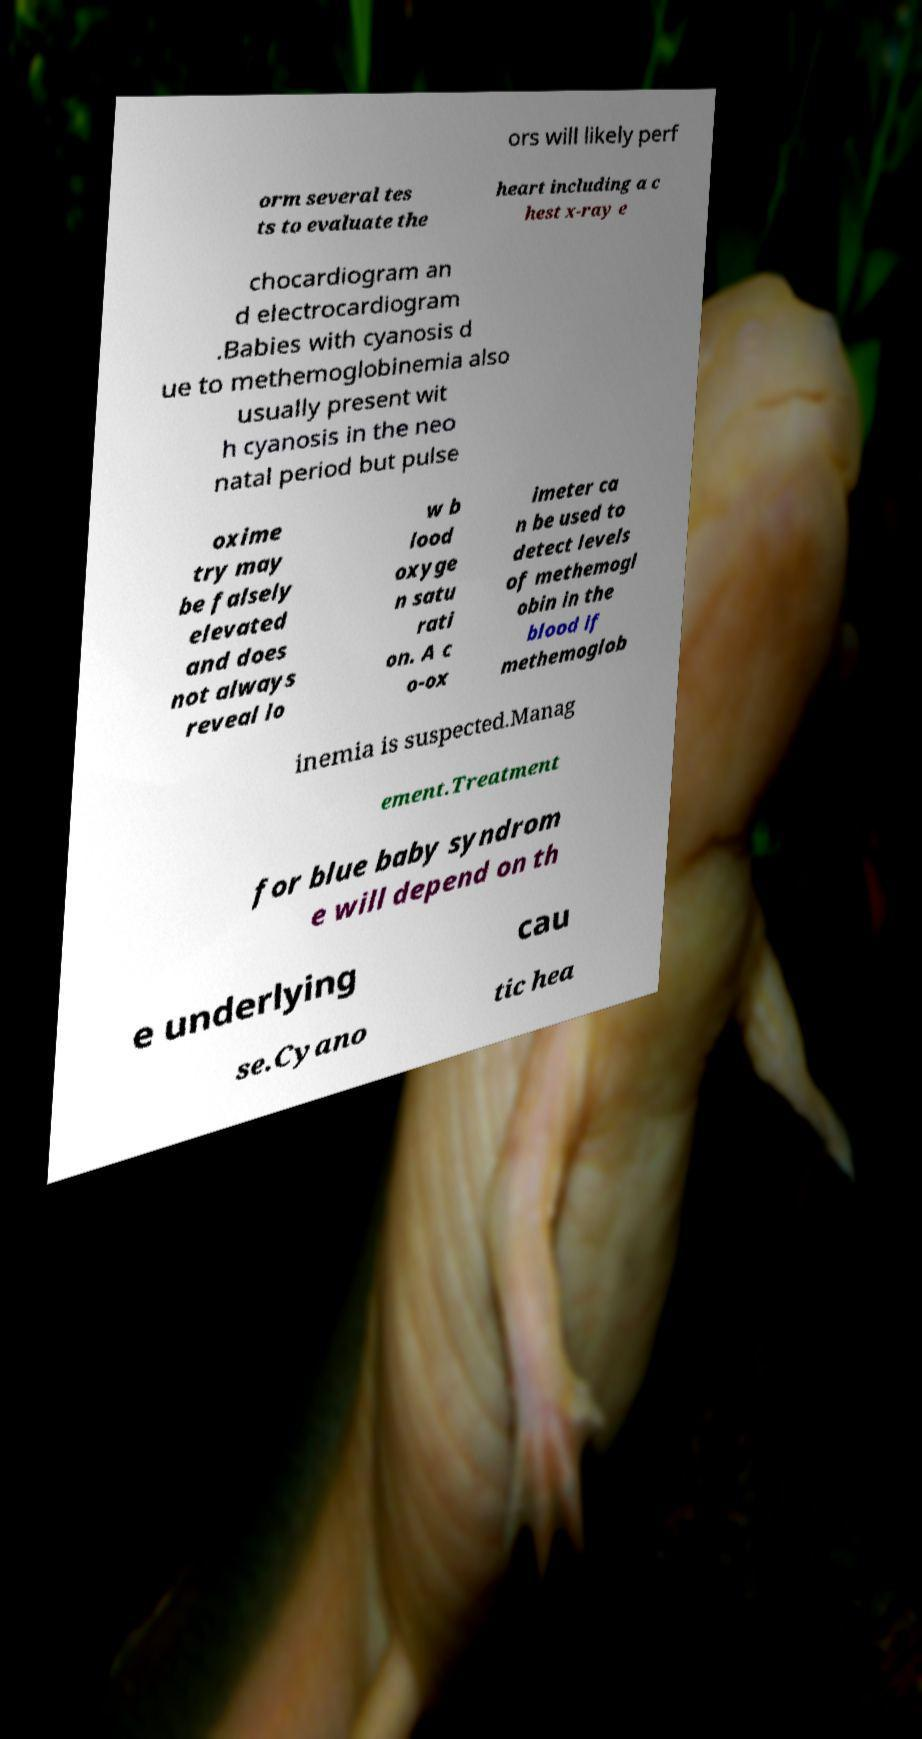Could you extract and type out the text from this image? ors will likely perf orm several tes ts to evaluate the heart including a c hest x-ray e chocardiogram an d electrocardiogram .Babies with cyanosis d ue to methemoglobinemia also usually present wit h cyanosis in the neo natal period but pulse oxime try may be falsely elevated and does not always reveal lo w b lood oxyge n satu rati on. A c o-ox imeter ca n be used to detect levels of methemogl obin in the blood if methemoglob inemia is suspected.Manag ement.Treatment for blue baby syndrom e will depend on th e underlying cau se.Cyano tic hea 